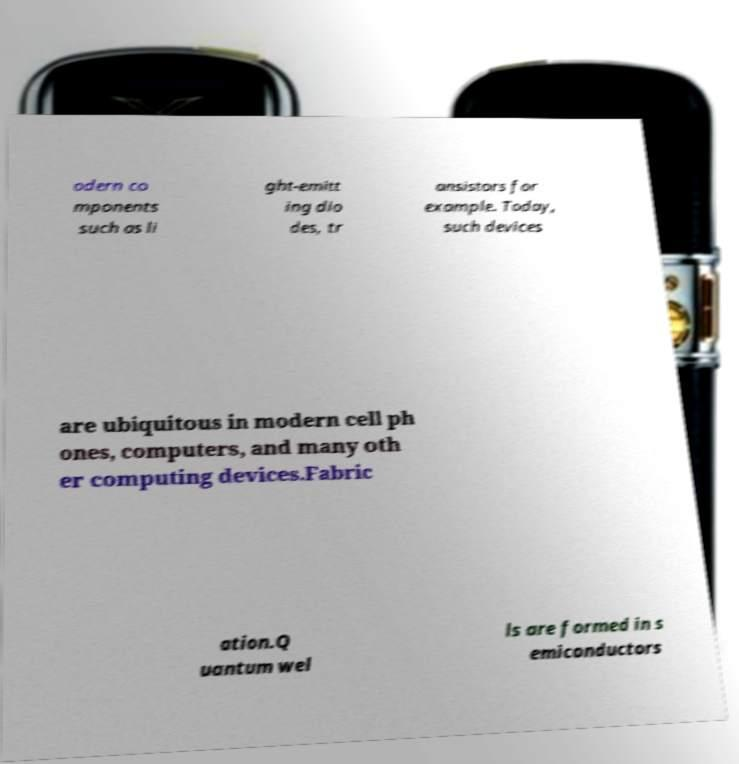Can you read and provide the text displayed in the image?This photo seems to have some interesting text. Can you extract and type it out for me? odern co mponents such as li ght-emitt ing dio des, tr ansistors for example. Today, such devices are ubiquitous in modern cell ph ones, computers, and many oth er computing devices.Fabric ation.Q uantum wel ls are formed in s emiconductors 